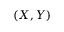<formula> <loc_0><loc_0><loc_500><loc_500>( X , Y )</formula> 